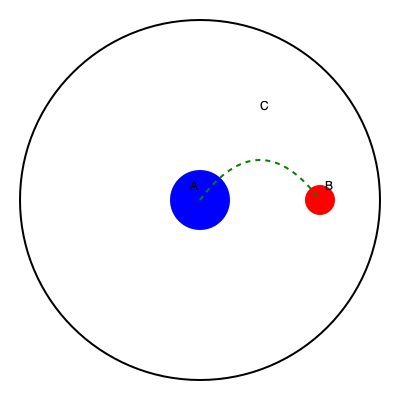In the diagram above, a spacecraft is traveling from point A to point B around a large celestial body. Given that the gravitational field is strongest near the surface of the celestial body, which path is most likely to represent the spacecraft's trajectory?

1. A straight line from A to B
2. The curved path shown in green
3. A path that curves away from the celestial body
4. A spiral path that gradually approaches B To determine the most likely trajectory of the spacecraft, we need to consider the effects of gravity on its path:

1. The large blue circle represents a celestial body with a strong gravitational field.
2. Point A is the starting position, and point B is the destination.
3. The gravitational field is strongest near the surface of the celestial body and decreases with distance.

Given these factors:

1. A straight line path is impossible due to the gravitational influence of the celestial body.
2. The green curved path shows the spacecraft using the gravitational field to assist its trajectory, known as a gravity assist or slingshot maneuver.
3. A path curving away from the celestial body would require constant propulsion against gravity, which is inefficient.
4. A spiral path would indicate the spacecraft is being captured by the gravitational field, not reaching its destination.

The curved path (option 2) is the most efficient and likely trajectory because:

a) It takes advantage of the gravitational field to accelerate the spacecraft.
b) It minimizes fuel consumption by using the celestial body's gravity to change direction.
c) This type of maneuver is commonly used in real space missions to conserve fuel and increase velocity.

The path's shape is determined by the spacecraft's initial velocity, the strength of the gravitational field, and the desired exit trajectory. The point C represents the closest approach to the celestial body, where the gravitational influence and spacecraft velocity are greatest.
Answer: The curved path shown in green (option 2) 